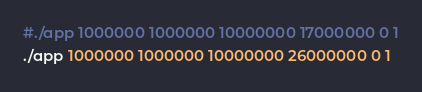Convert code to text. <code><loc_0><loc_0><loc_500><loc_500><_Bash_>#./app 1000000 1000000 10000000 17000000 0 1
./app 1000000 1000000 10000000 26000000 0 1
</code> 